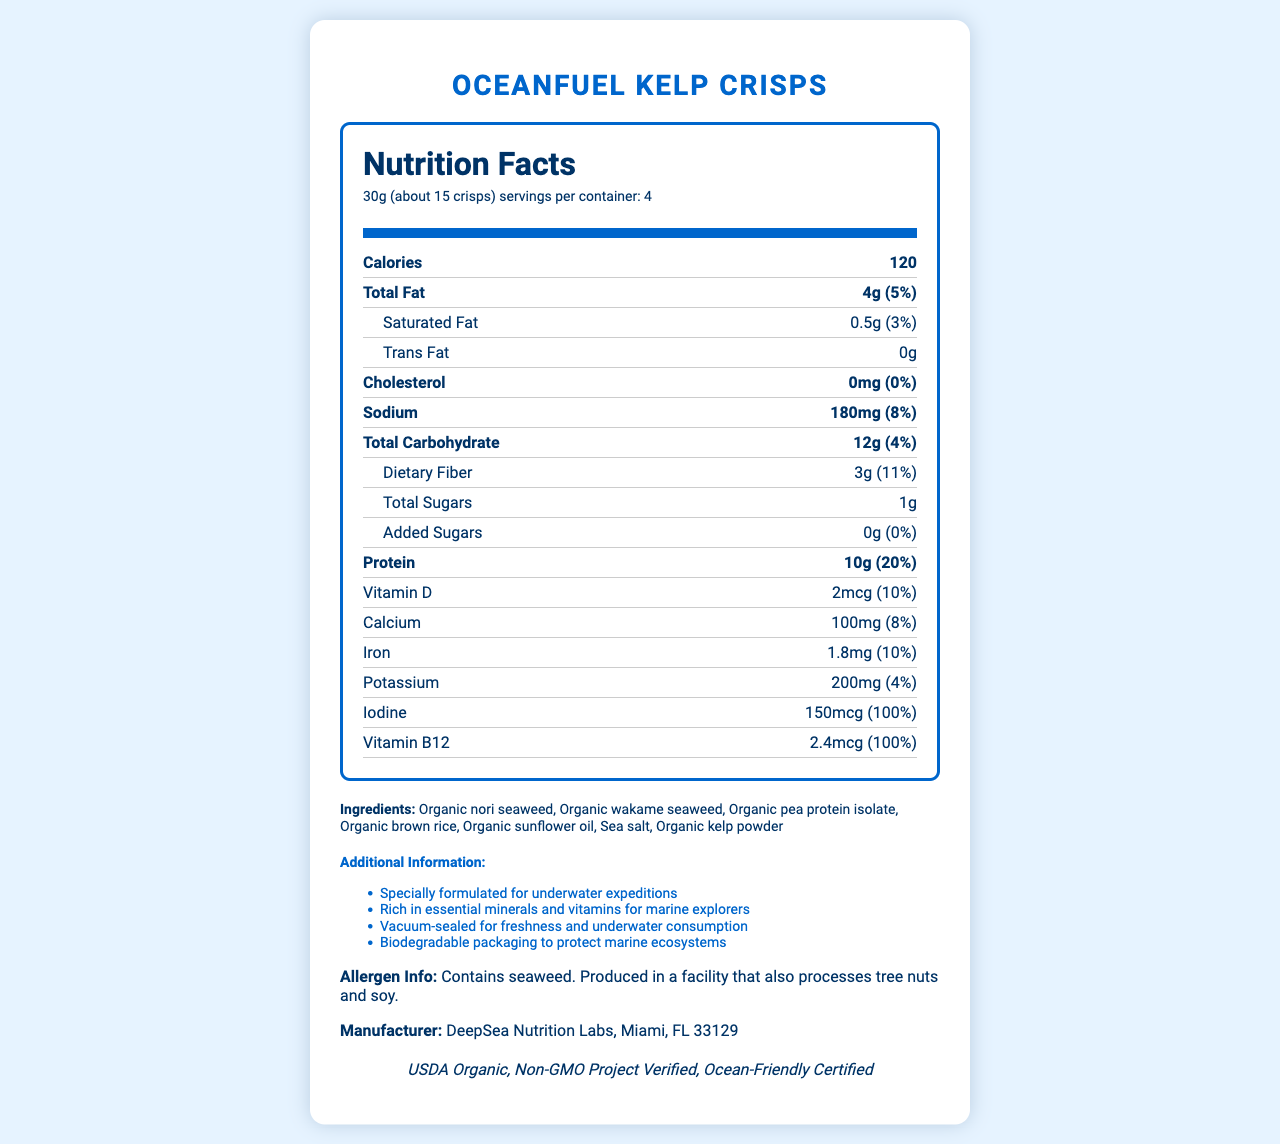what is the serving size for OceanFuel Kelp Crisps? The serving size is listed as 30g, which is approximately 15 crisps according to the document.
Answer: 30g (about 15 crisps) What is the total number of calories per serving? The calories per serving is clearly stated as 120 in the document.
Answer: 120 How much protein does one serving contain? The protein content per serving is listed as 10g in the nutrition facts section.
Answer: 10g What are the ingredients in OceanFuel Kelp Crisps? The ingredients are listed in the document under the ingredients section.
Answer: Organic nori seaweed, Organic wakame seaweed, Organic pea protein isolate, Organic brown rice, Organic sunflower oil, Sea salt, Organic kelp powder What is the sodium content per serving and its daily value percentage? The sodium content is 180mg per serving and it constitutes 8% of the daily value.
Answer: 180mg, 8% Which of the following nutrients is found in the highest daily value percentage in the crisps? A. Vitamin D B. Calcium C. Iodine D. Protein Iodine has the highest daily value percentage of 100% among all listed nutrients.
Answer: C. Iodine What is the expiration date of the product? A. January 2023 B. June 2023 C. December 2023 D. Not mentioned The document does not provide any information about the expiration date of the product.
Answer: D. Not mentioned Is the product certified organic? The document mentions that the product is USDA Organic certified.
Answer: Yes Summarize the main nutritional benefits of OceanFuel Kelp Crisps. The ingredients and nutritional content, along with the product's certification and mission statements, highlight its main nutritional benefits.
Answer: The crisps are high in protein, low in saturated fat, and rich in essential vitamins and minerals such as iodine and vitamin B12. They are formulated for underwater expeditions, providing a convenient and nutritious snack for marine explorers. What is the address of the manufacturer? The manufacturer's address is provided at the end of the document.
Answer: DeepSea Nutrition Labs, Miami, FL 33129 What is the total fiber content per serving, and how does it contribute to the daily value? The fiber content is 3g per serving and it contributes 11% to the daily value according to the nutrition facts.
Answer: 3g, 11% Are OceanFuel Kelp Crisps suitable for individuals with tree nut allergies? The document states the crisps are produced in a facility that also processes tree nuts, making it unclear if they are safe for individuals with tree nut allergies.
Answer: Not enough information 